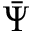Convert formula to latex. <formula><loc_0><loc_0><loc_500><loc_500>\bar { \Psi }</formula> 